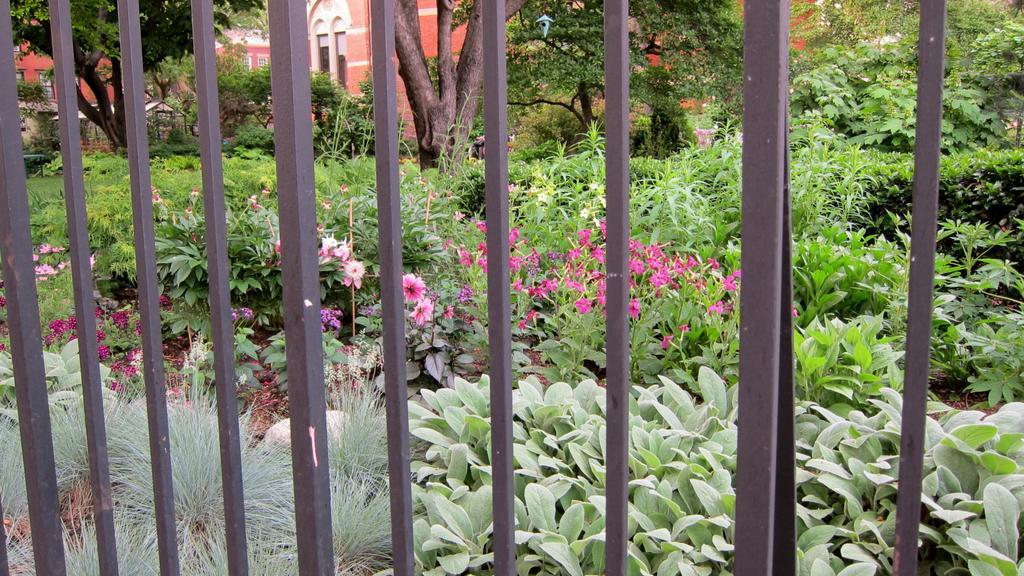Please provide a concise description of this image. In the center of the image there is a building and we can see trees. At the bottom there are plants and grass. We can see flowers. In the foreground there is a grille. 